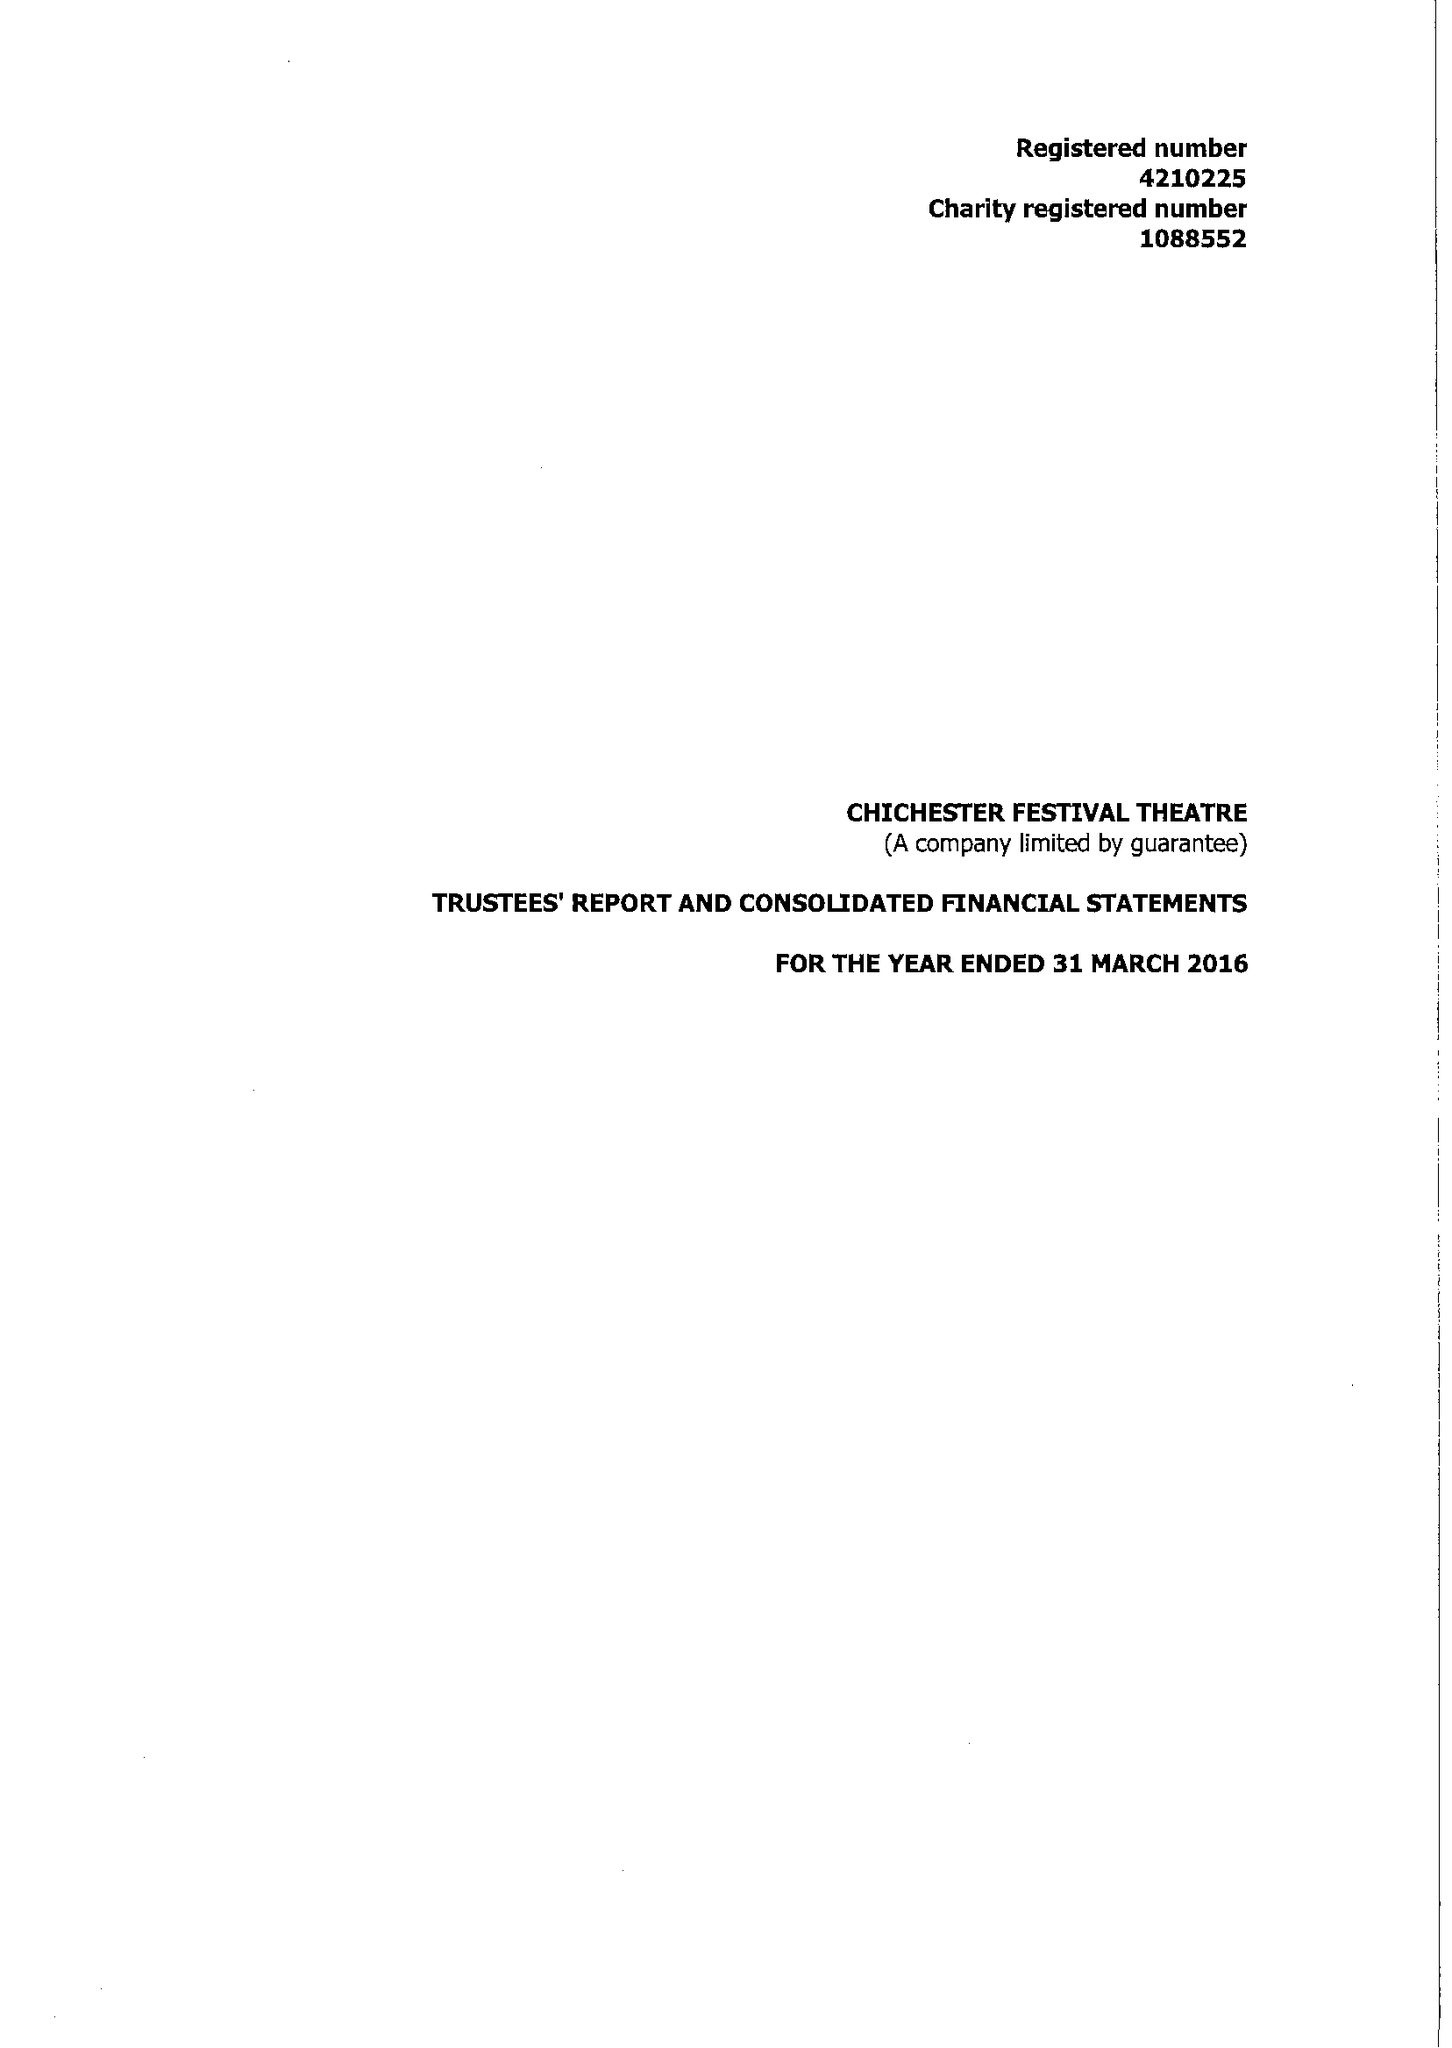What is the value for the address__street_line?
Answer the question using a single word or phrase. OAKLANDS PARK 